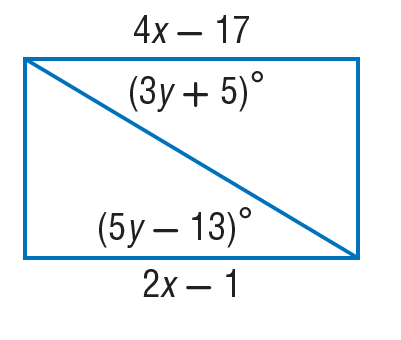Question: Find y so that the quadrilateral is a parallelogram.
Choices:
A. 1
B. 9
C. 17
D. 29
Answer with the letter. Answer: B Question: Find y so that the quadrilateral is a parallelogram.
Choices:
A. 9
B. 13
C. 18
D. 19
Answer with the letter. Answer: A Question: Find x so that the quadrilateral is a parallelogram.
Choices:
A. 8
B. 9
C. 18
D. 19
Answer with the letter. Answer: A 